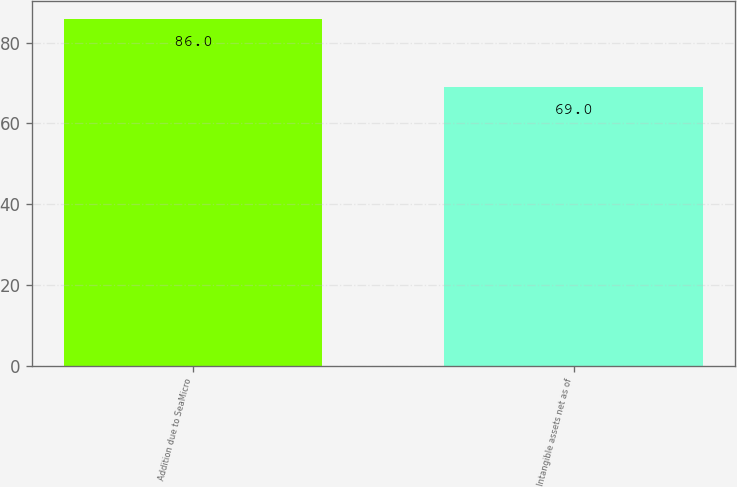<chart> <loc_0><loc_0><loc_500><loc_500><bar_chart><fcel>Addition due to SeaMicro<fcel>Intangible assets net as of<nl><fcel>86<fcel>69<nl></chart> 